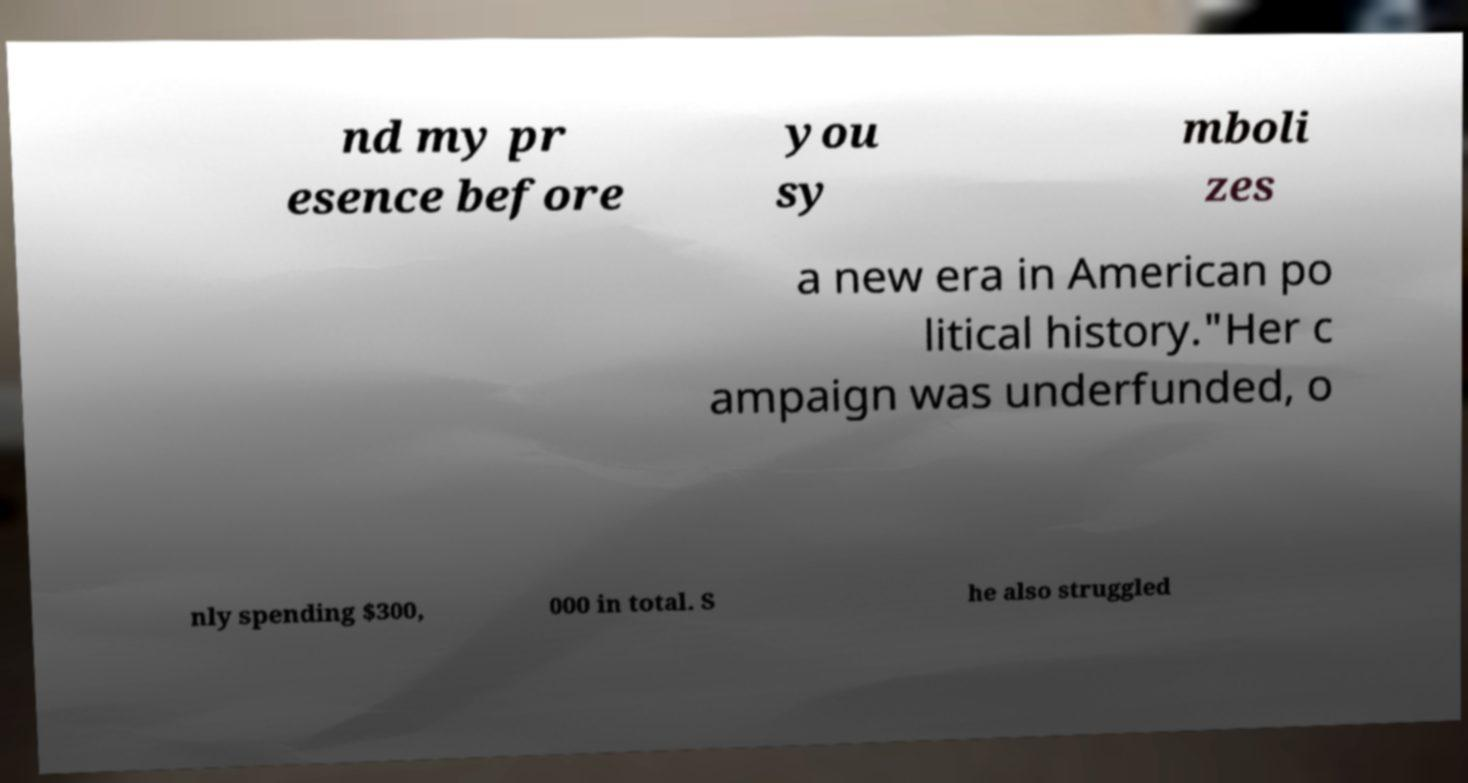There's text embedded in this image that I need extracted. Can you transcribe it verbatim? nd my pr esence before you sy mboli zes a new era in American po litical history."Her c ampaign was underfunded, o nly spending $300, 000 in total. S he also struggled 